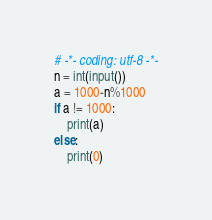Convert code to text. <code><loc_0><loc_0><loc_500><loc_500><_Python_># -*- coding: utf-8 -*-
n = int(input())
a = 1000-n%1000
if a != 1000:
    print(a)
else:
    print(0)</code> 